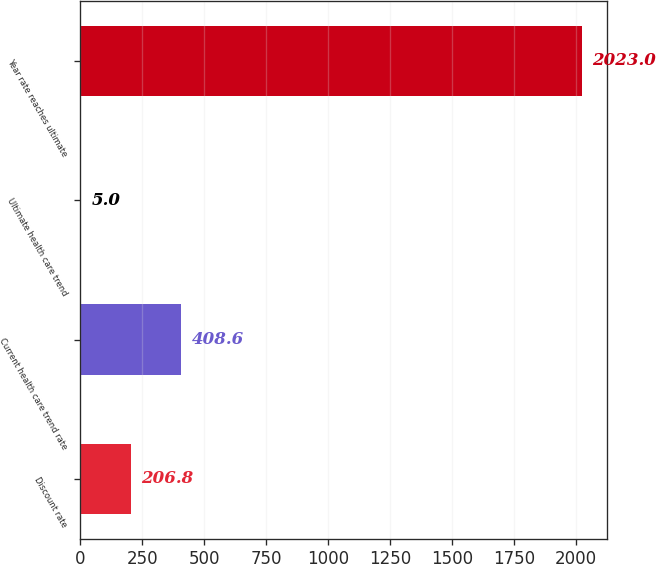Convert chart. <chart><loc_0><loc_0><loc_500><loc_500><bar_chart><fcel>Discount rate<fcel>Current health care trend rate<fcel>Ultimate health care trend<fcel>Year rate reaches ultimate<nl><fcel>206.8<fcel>408.6<fcel>5<fcel>2023<nl></chart> 